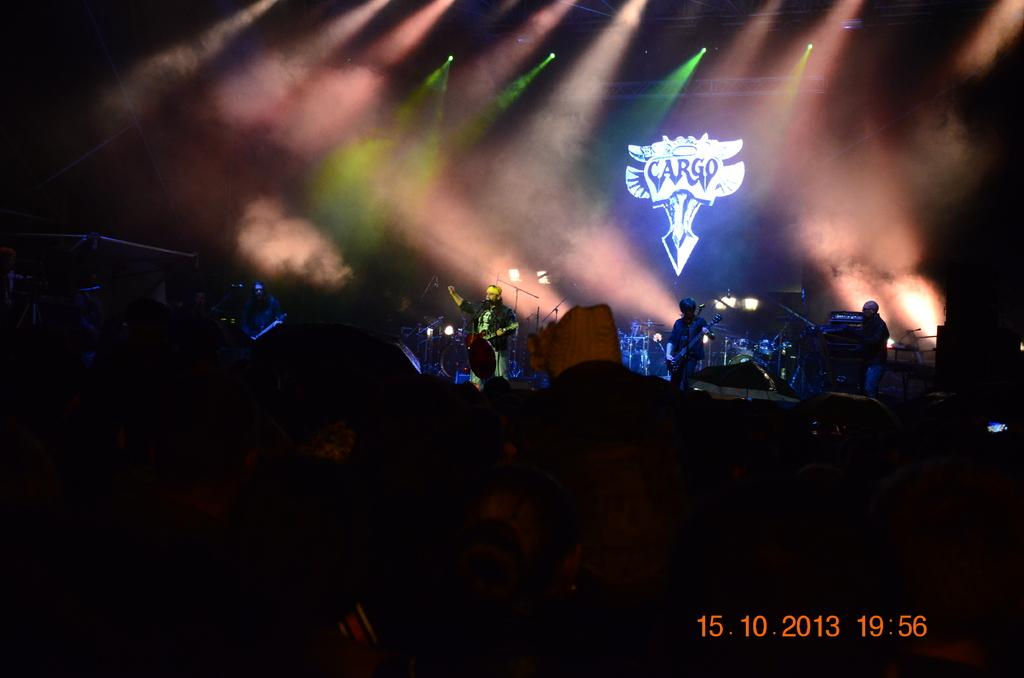What are the people on the stage doing? The people on the stage are playing guitar and other music instruments. What can be seen behind the stage? There is a banner behind the stage. What is present above the stage? There are lights above the stage. How many ants can be seen crawling on the guitar in the image? There are no ants present in the image; the focus is on the people playing music instruments. 